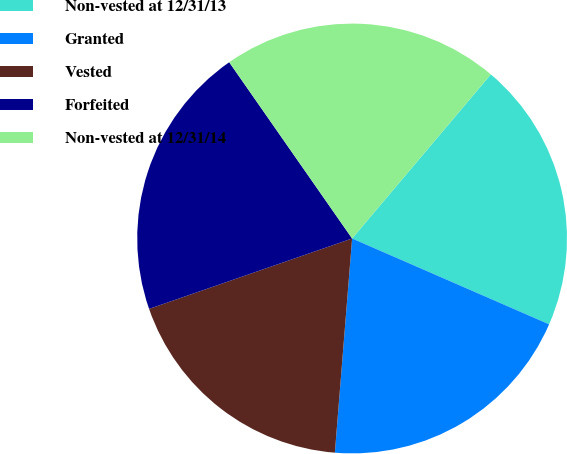Convert chart to OTSL. <chart><loc_0><loc_0><loc_500><loc_500><pie_chart><fcel>Non-vested at 12/31/13<fcel>Granted<fcel>Vested<fcel>Forfeited<fcel>Non-vested at 12/31/14<nl><fcel>20.37%<fcel>19.74%<fcel>18.41%<fcel>20.62%<fcel>20.86%<nl></chart> 